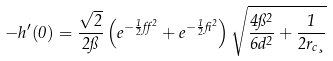<formula> <loc_0><loc_0><loc_500><loc_500>- h ^ { \prime } ( 0 ) = \frac { \sqrt { 2 } } { 2 \pi } \left ( e ^ { - \frac { 1 } { 2 } { \alpha ^ { 2 } } } + e ^ { - \frac { 1 } { 2 } \beta ^ { 2 } } \right ) \sqrt { \frac { 4 \pi ^ { 2 } } { 6 d ^ { 2 } } + \frac { 1 } { 2 r _ { c } \xi } }</formula> 